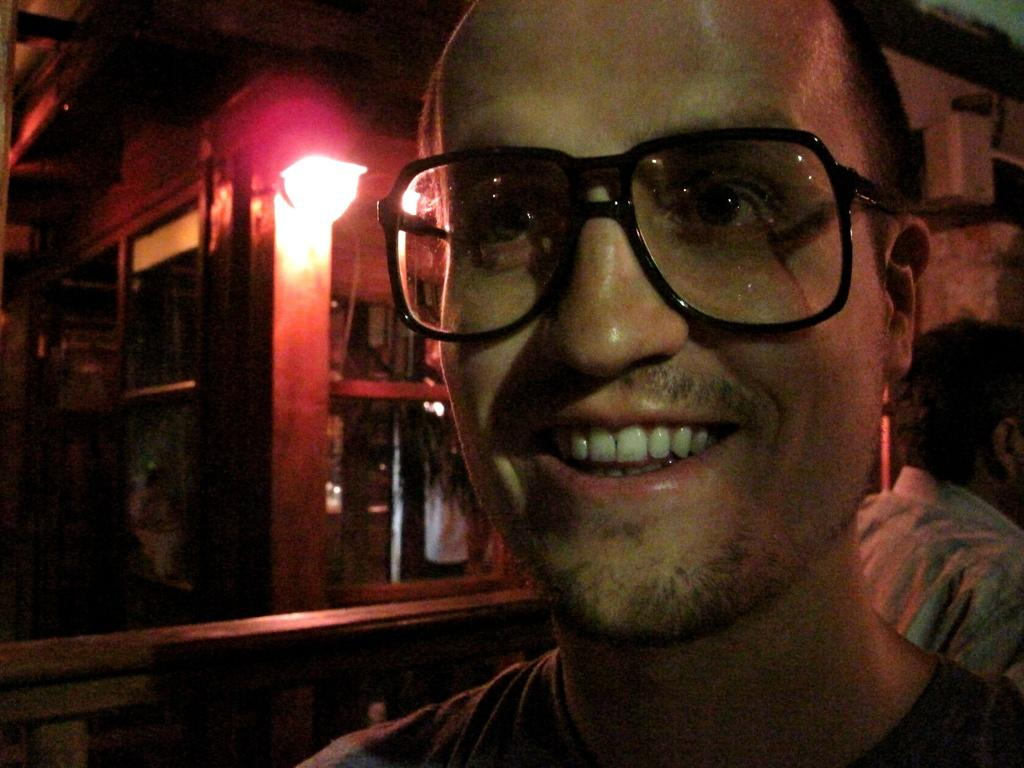What can be seen on the right side of the image? There is a person on the right side of the image. What is the person wearing? The person is wearing spectacles. What is the person's facial expression? The person is smiling. Can you describe the background of the image? There are windows, a light, a roof, and other objects in the background of the image. How many people are visible in the image? There are two people visible in the image. What type of books does the person have on their head in the image? There are no books present in the image, and therefore no such activity can be observed. What religious symbols can be seen in the image? There is no mention of any religious symbols in the image. 